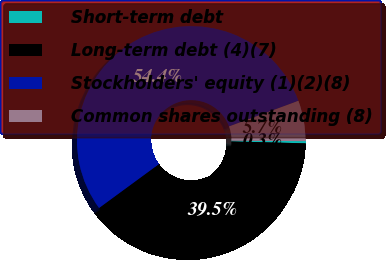Convert chart to OTSL. <chart><loc_0><loc_0><loc_500><loc_500><pie_chart><fcel>Short-term debt<fcel>Long-term debt (4)(7)<fcel>Stockholders' equity (1)(2)(8)<fcel>Common shares outstanding (8)<nl><fcel>0.31%<fcel>39.52%<fcel>54.44%<fcel>5.73%<nl></chart> 